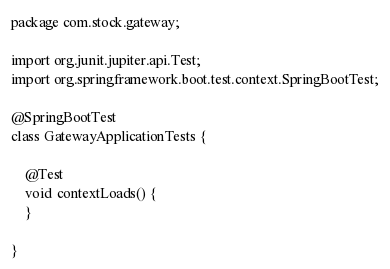<code> <loc_0><loc_0><loc_500><loc_500><_Java_>package com.stock.gateway;

import org.junit.jupiter.api.Test;
import org.springframework.boot.test.context.SpringBootTest;

@SpringBootTest
class GatewayApplicationTests {

	@Test
	void contextLoads() {
	}

}
</code> 